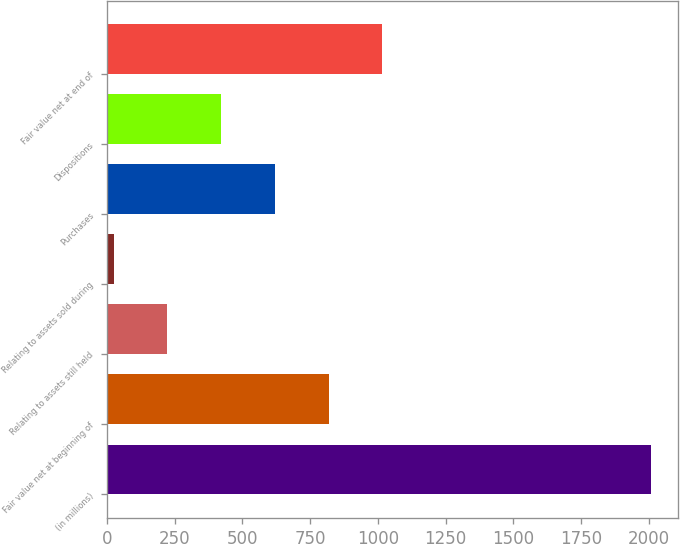Convert chart to OTSL. <chart><loc_0><loc_0><loc_500><loc_500><bar_chart><fcel>(in millions)<fcel>Fair value net at beginning of<fcel>Relating to assets still held<fcel>Relating to assets sold during<fcel>Purchases<fcel>Dispositions<fcel>Fair value net at end of<nl><fcel>2010<fcel>818.4<fcel>222.6<fcel>24<fcel>619.8<fcel>421.2<fcel>1017<nl></chart> 